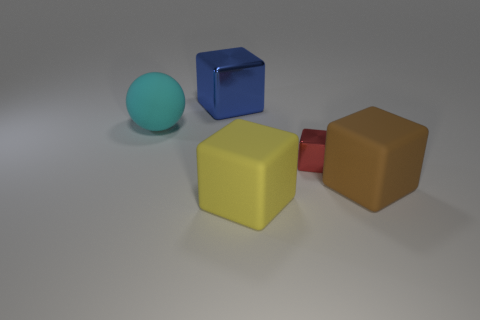How many big cyan objects are the same material as the yellow object?
Your answer should be compact. 1. Is there a brown ball?
Offer a very short reply. No. What is the size of the metal cube on the right side of the big metallic block?
Provide a succinct answer. Small. How many spheres are large cyan objects or big brown things?
Make the answer very short. 1. The large object that is right of the ball and behind the big brown cube has what shape?
Your answer should be very brief. Cube. Are there any rubber balls that have the same size as the brown rubber block?
Offer a very short reply. Yes. What number of things are either matte cubes on the left side of the red block or big brown objects?
Provide a short and direct response. 2. Does the big brown cube have the same material as the yellow thing to the left of the small shiny block?
Offer a very short reply. Yes. How many other objects are there of the same shape as the cyan object?
Ensure brevity in your answer.  0. How many things are either matte things that are right of the big blue metallic object or cubes that are in front of the big cyan sphere?
Give a very brief answer. 3. 